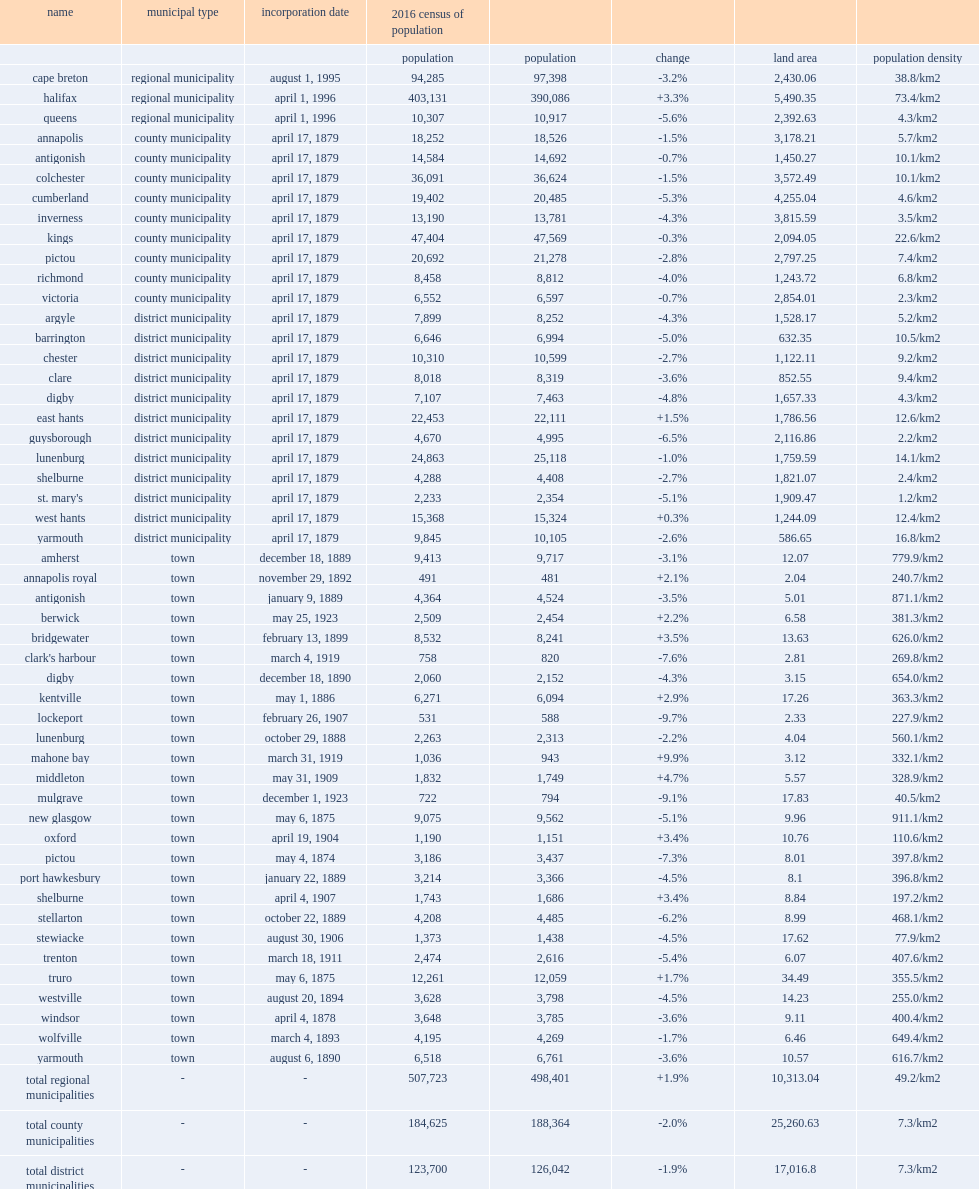What is the type of west hants in nova scotia? District municipality. 